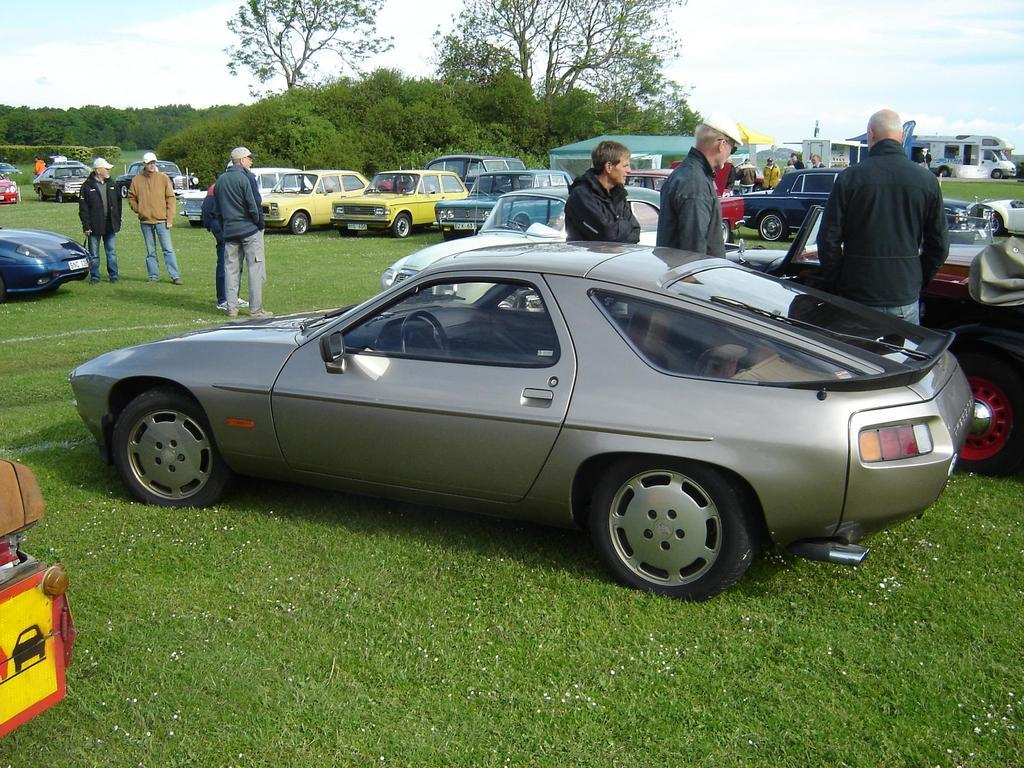What can be seen in the image involving people? There are people standing in the image. What else is present in the image besides people? There are vehicles in the image. What type of natural scenery is visible in the background of the image? There are trees in the background of the image. What part of the environment is visible at the bottom of the image? The ground is visible at the bottom of the image. What part of the environment is visible at the top of the image? The sky is visible at the top of the image. How many firemen are riding bikes in the image? There are no firemen or bikes present in the image. What type of lift can be seen in the image? There is: There is no lift visible in the image. 